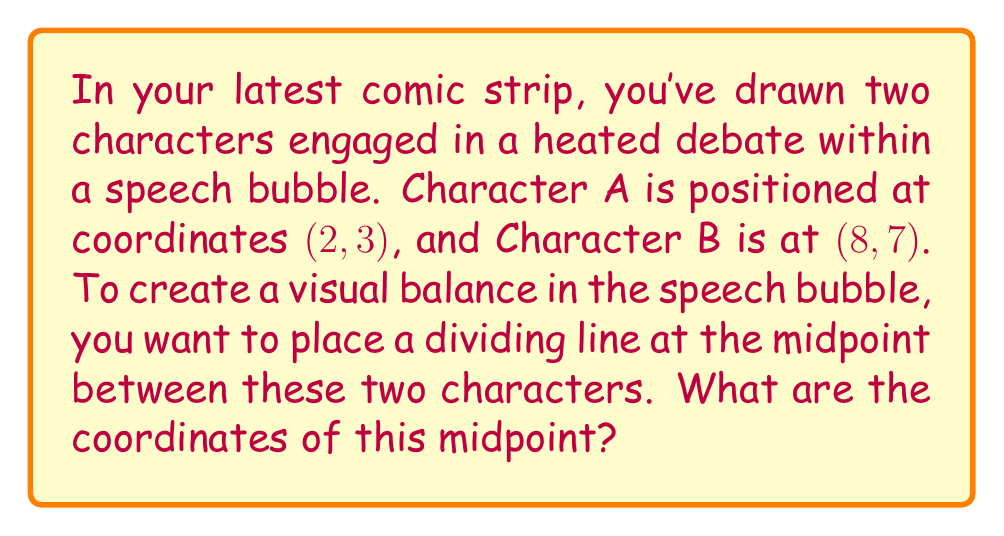Solve this math problem. To find the midpoint between two points in a coordinate system, we use the midpoint formula:

$$ \text{Midpoint} = \left(\frac{x_1 + x_2}{2}, \frac{y_1 + y_2}{2}\right) $$

Where $(x_1, y_1)$ are the coordinates of the first point and $(x_2, y_2)$ are the coordinates of the second point.

In this case:
- Character A is at $(x_1, y_1) = (2, 3)$
- Character B is at $(x_2, y_2) = (8, 7)$

Let's substitute these values into the midpoint formula:

$$ \text{Midpoint} = \left(\frac{2 + 8}{2}, \frac{3 + 7}{2}\right) $$

Now, let's calculate each coordinate:

For the x-coordinate:
$$ \frac{2 + 8}{2} = \frac{10}{2} = 5 $$

For the y-coordinate:
$$ \frac{3 + 7}{2} = \frac{10}{2} = 5 $$

Therefore, the midpoint coordinates are (5, 5).

[asy]
unitsize(1cm);
draw((-1,-1)--(10,9), gray);
draw((-1,9)--(10,-1), gray);
for(int i=-1; i<=10; ++i) {
  draw((i,-1)--(i,9), gray+0.5bp);
  draw((-1,i)--(10,i), gray+0.5bp);
}
dot((2,3), red);
dot((8,7), red);
dot((5,5), blue);
label("A (2,3)", (2,3), SW, red);
label("B (8,7)", (8,7), NE, red);
label("Midpoint (5,5)", (5,5), SE, blue);
[/asy]
Answer: The coordinates of the midpoint are (5, 5). 